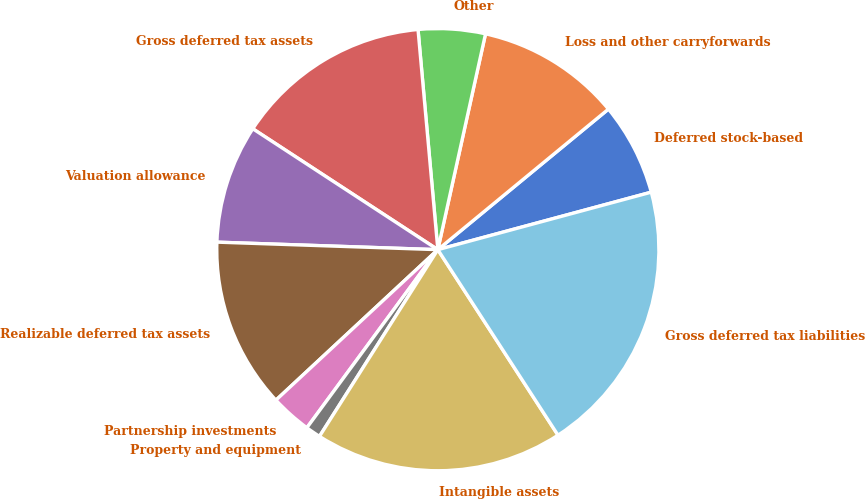<chart> <loc_0><loc_0><loc_500><loc_500><pie_chart><fcel>Deferred stock-based<fcel>Loss and other carryforwards<fcel>Other<fcel>Gross deferred tax assets<fcel>Valuation allowance<fcel>Realizable deferred tax assets<fcel>Partnership investments<fcel>Property and equipment<fcel>Intangible assets<fcel>Gross deferred tax liabilities<nl><fcel>6.78%<fcel>10.57%<fcel>4.89%<fcel>14.36%<fcel>8.67%<fcel>12.46%<fcel>2.99%<fcel>1.1%<fcel>18.14%<fcel>20.04%<nl></chart> 